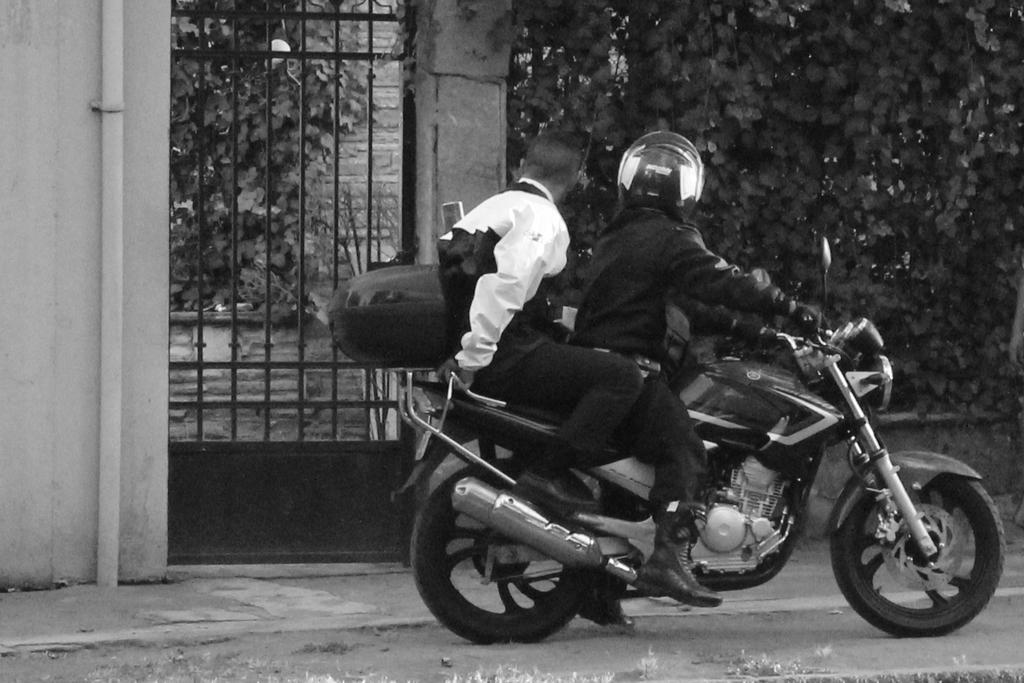Please provide a concise description of this image. There are two persons sitting on a bike, which is on the road. In the background, there are trees, gate, wall and a pipe. 